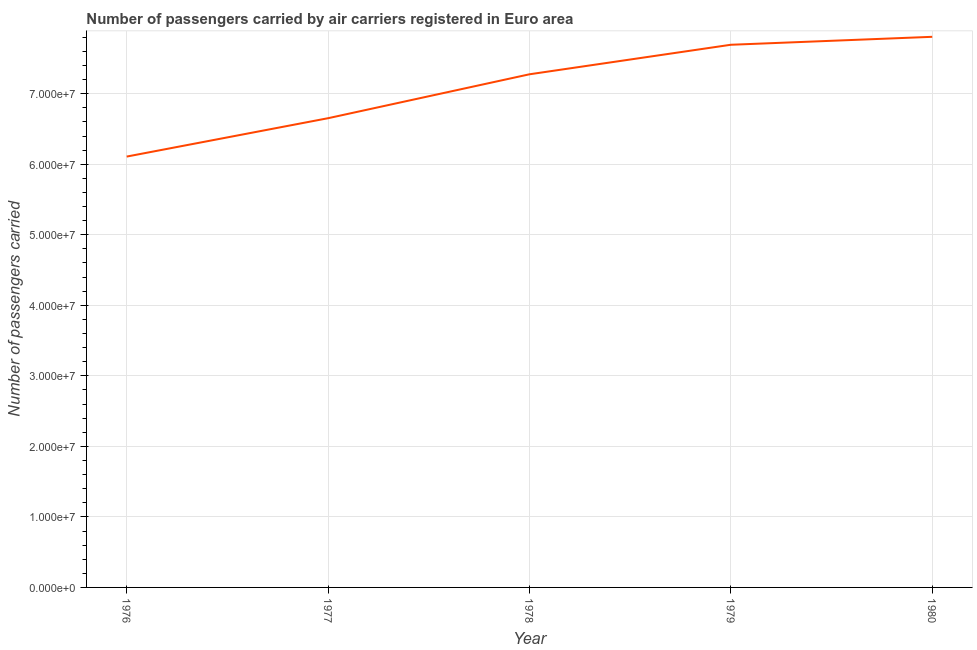What is the number of passengers carried in 1979?
Ensure brevity in your answer.  7.69e+07. Across all years, what is the maximum number of passengers carried?
Your response must be concise. 7.81e+07. Across all years, what is the minimum number of passengers carried?
Provide a short and direct response. 6.11e+07. In which year was the number of passengers carried maximum?
Provide a short and direct response. 1980. In which year was the number of passengers carried minimum?
Your response must be concise. 1976. What is the sum of the number of passengers carried?
Offer a very short reply. 3.55e+08. What is the difference between the number of passengers carried in 1979 and 1980?
Provide a succinct answer. -1.13e+06. What is the average number of passengers carried per year?
Offer a terse response. 7.11e+07. What is the median number of passengers carried?
Your answer should be very brief. 7.28e+07. What is the ratio of the number of passengers carried in 1978 to that in 1979?
Your answer should be very brief. 0.95. Is the difference between the number of passengers carried in 1977 and 1980 greater than the difference between any two years?
Ensure brevity in your answer.  No. What is the difference between the highest and the second highest number of passengers carried?
Your response must be concise. 1.13e+06. Is the sum of the number of passengers carried in 1977 and 1978 greater than the maximum number of passengers carried across all years?
Offer a very short reply. Yes. What is the difference between the highest and the lowest number of passengers carried?
Offer a terse response. 1.70e+07. In how many years, is the number of passengers carried greater than the average number of passengers carried taken over all years?
Give a very brief answer. 3. What is the difference between two consecutive major ticks on the Y-axis?
Ensure brevity in your answer.  1.00e+07. Are the values on the major ticks of Y-axis written in scientific E-notation?
Your answer should be compact. Yes. What is the title of the graph?
Make the answer very short. Number of passengers carried by air carriers registered in Euro area. What is the label or title of the Y-axis?
Ensure brevity in your answer.  Number of passengers carried. What is the Number of passengers carried in 1976?
Give a very brief answer. 6.11e+07. What is the Number of passengers carried of 1977?
Offer a very short reply. 6.65e+07. What is the Number of passengers carried in 1978?
Ensure brevity in your answer.  7.28e+07. What is the Number of passengers carried in 1979?
Ensure brevity in your answer.  7.69e+07. What is the Number of passengers carried in 1980?
Make the answer very short. 7.81e+07. What is the difference between the Number of passengers carried in 1976 and 1977?
Keep it short and to the point. -5.44e+06. What is the difference between the Number of passengers carried in 1976 and 1978?
Keep it short and to the point. -1.17e+07. What is the difference between the Number of passengers carried in 1976 and 1979?
Keep it short and to the point. -1.59e+07. What is the difference between the Number of passengers carried in 1976 and 1980?
Your response must be concise. -1.70e+07. What is the difference between the Number of passengers carried in 1977 and 1978?
Offer a very short reply. -6.23e+06. What is the difference between the Number of passengers carried in 1977 and 1979?
Your answer should be very brief. -1.04e+07. What is the difference between the Number of passengers carried in 1977 and 1980?
Your answer should be compact. -1.15e+07. What is the difference between the Number of passengers carried in 1978 and 1979?
Keep it short and to the point. -4.19e+06. What is the difference between the Number of passengers carried in 1978 and 1980?
Offer a very short reply. -5.31e+06. What is the difference between the Number of passengers carried in 1979 and 1980?
Your answer should be compact. -1.13e+06. What is the ratio of the Number of passengers carried in 1976 to that in 1977?
Give a very brief answer. 0.92. What is the ratio of the Number of passengers carried in 1976 to that in 1978?
Your answer should be compact. 0.84. What is the ratio of the Number of passengers carried in 1976 to that in 1979?
Make the answer very short. 0.79. What is the ratio of the Number of passengers carried in 1976 to that in 1980?
Your response must be concise. 0.78. What is the ratio of the Number of passengers carried in 1977 to that in 1978?
Provide a succinct answer. 0.91. What is the ratio of the Number of passengers carried in 1977 to that in 1979?
Provide a short and direct response. 0.86. What is the ratio of the Number of passengers carried in 1977 to that in 1980?
Ensure brevity in your answer.  0.85. What is the ratio of the Number of passengers carried in 1978 to that in 1979?
Ensure brevity in your answer.  0.95. What is the ratio of the Number of passengers carried in 1978 to that in 1980?
Your answer should be very brief. 0.93. 